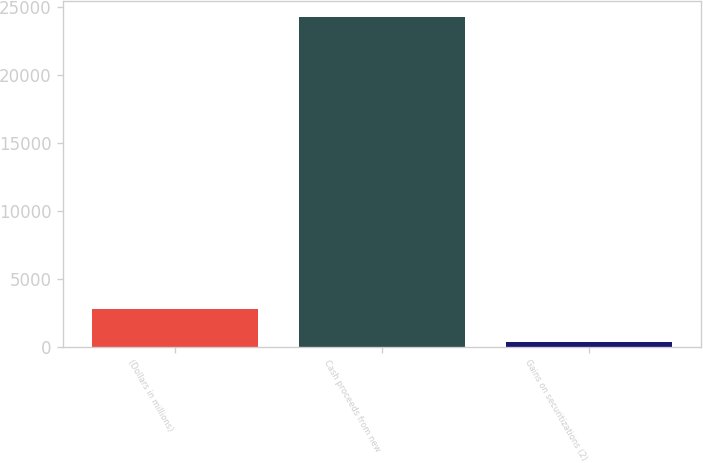Convert chart. <chart><loc_0><loc_0><loc_500><loc_500><bar_chart><fcel>(Dollars in millions)<fcel>Cash proceeds from new<fcel>Gains on securitizations (2)<nl><fcel>2753.1<fcel>24201<fcel>370<nl></chart> 